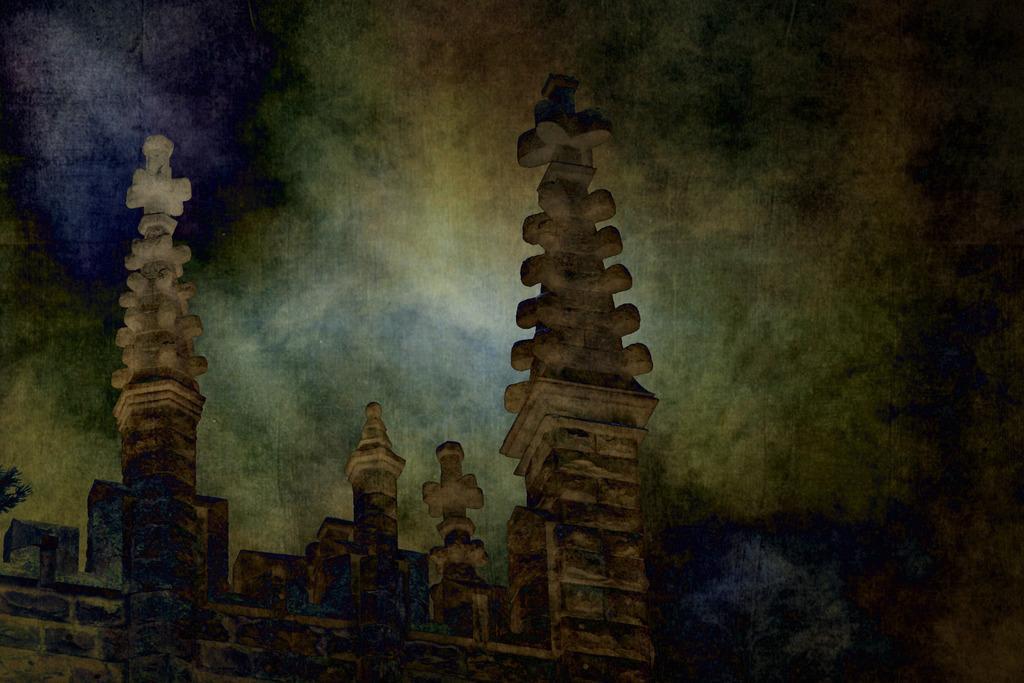Please provide a concise description of this image. In this image we can see the castle construction. Here we can see the ancient pillars on the top. This is a sky with clouds. 